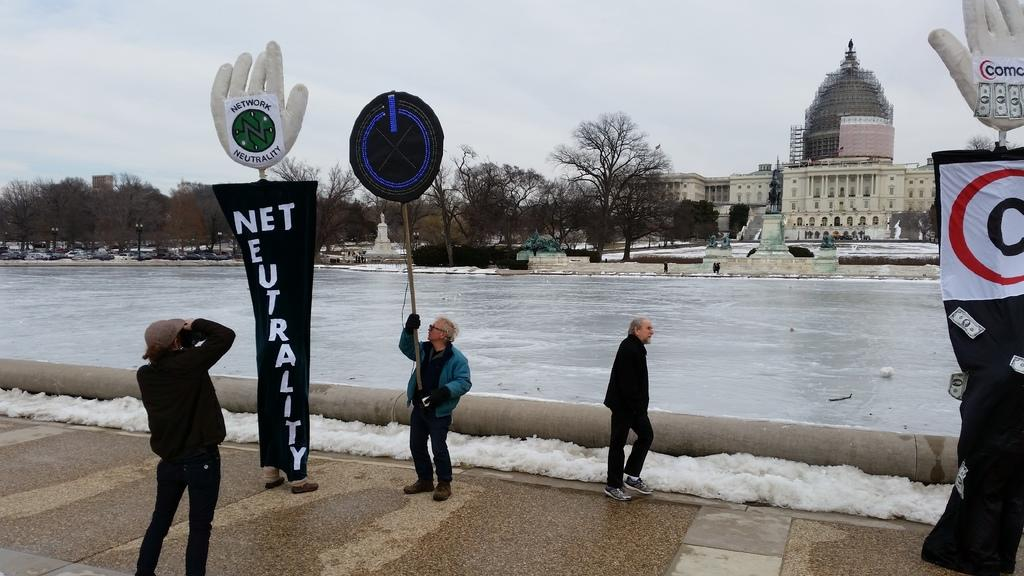<image>
Offer a succinct explanation of the picture presented. men standing next to a sign which says "Net Neutrality". 